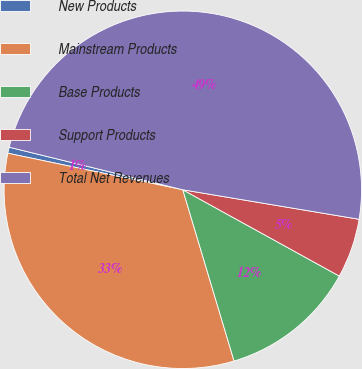Convert chart. <chart><loc_0><loc_0><loc_500><loc_500><pie_chart><fcel>New Products<fcel>Mainstream Products<fcel>Base Products<fcel>Support Products<fcel>Total Net Revenues<nl><fcel>0.55%<fcel>32.91%<fcel>12.35%<fcel>5.38%<fcel>48.81%<nl></chart> 